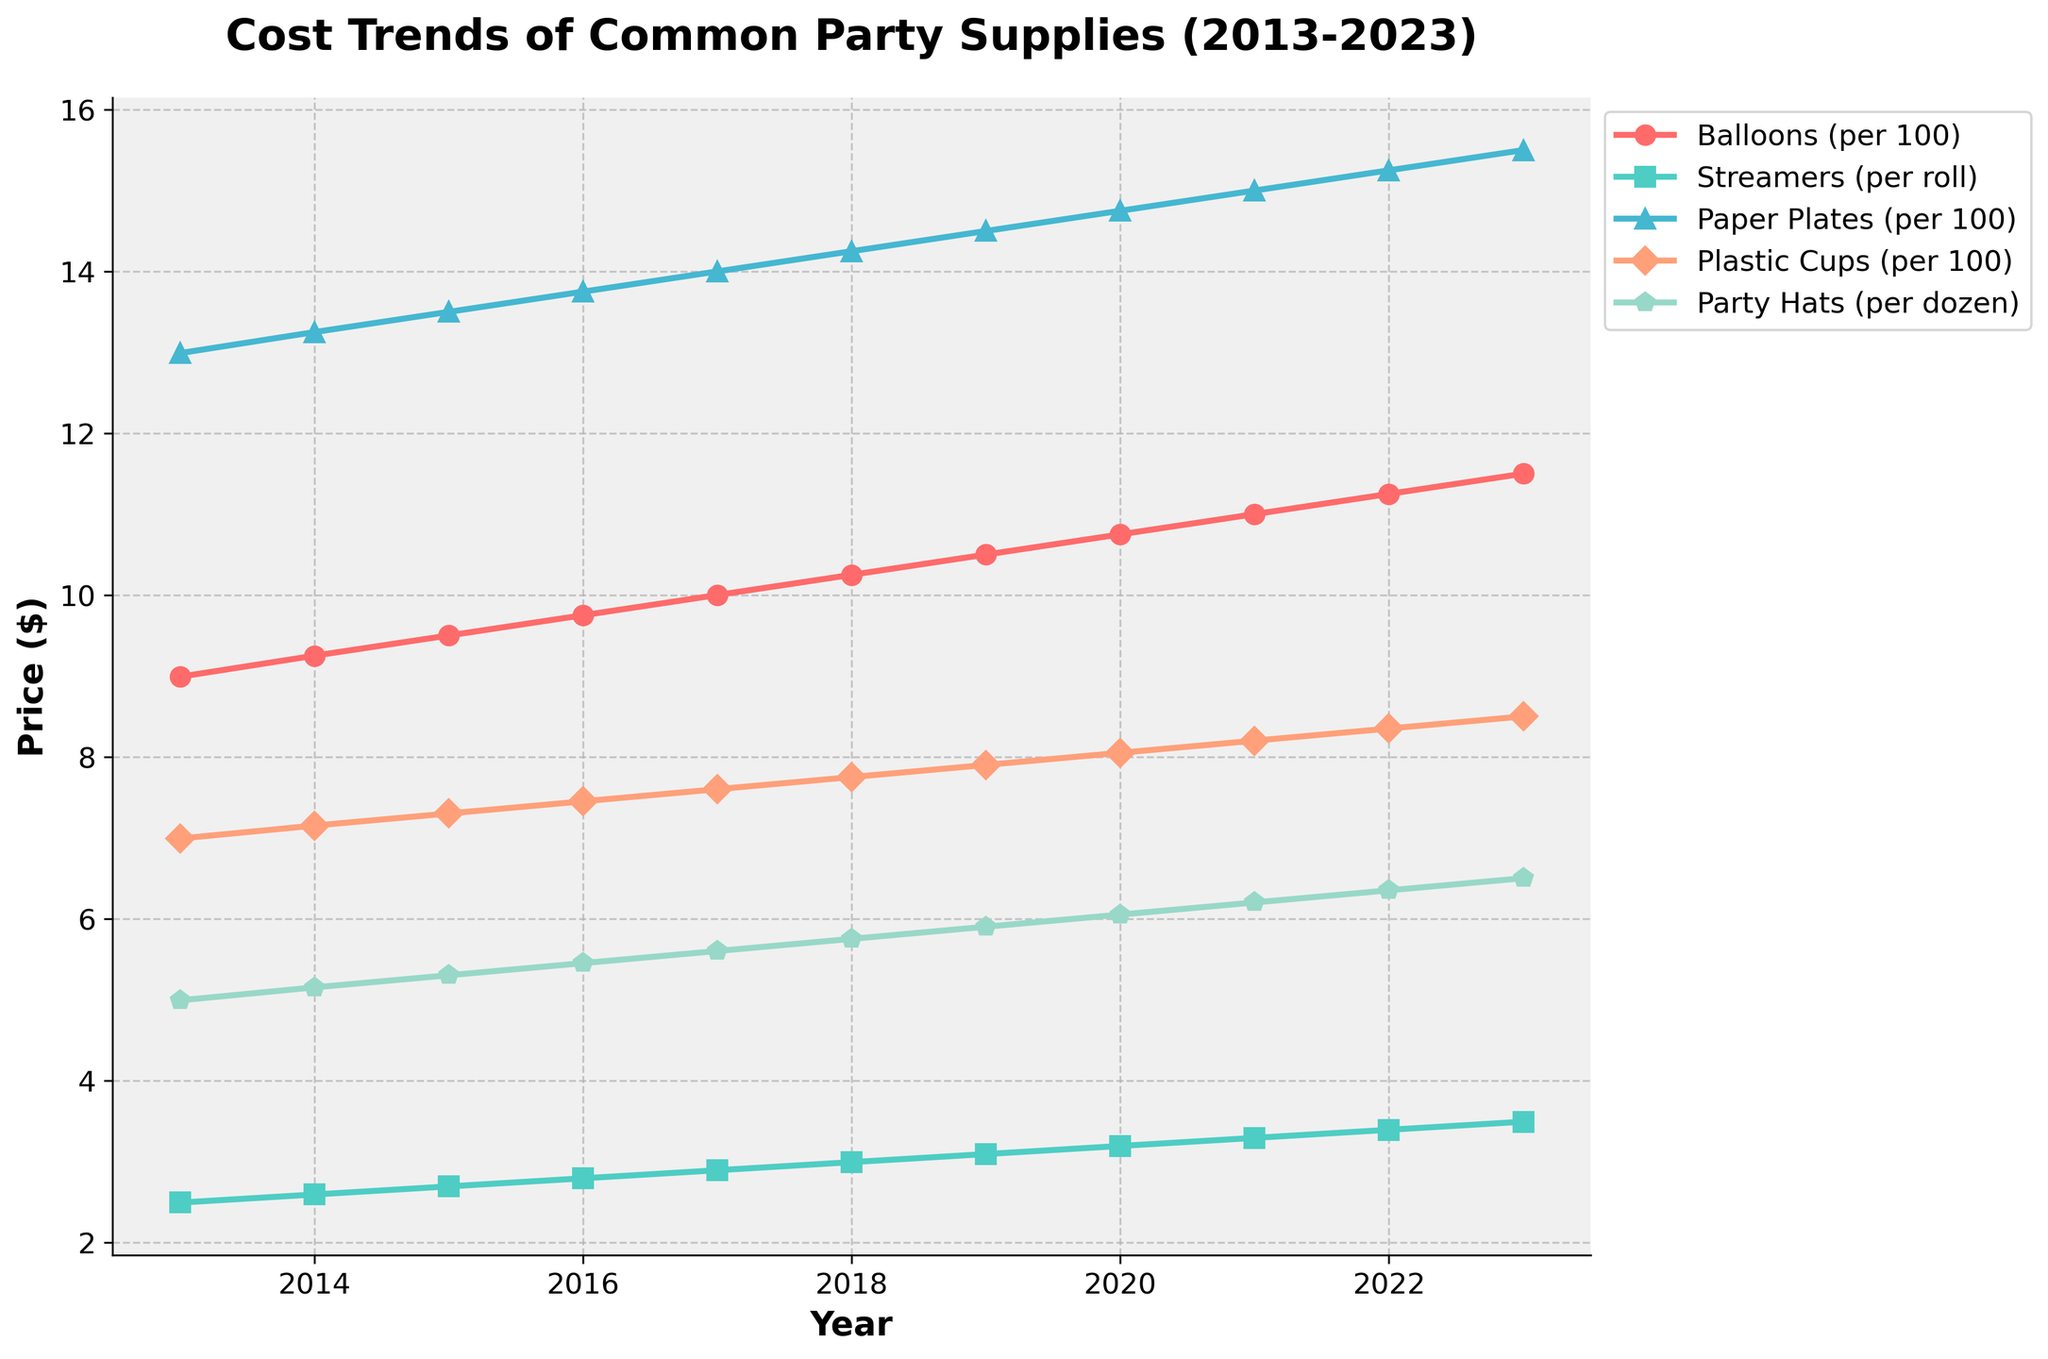What's the trend in the price of Party Hats from 2013 to 2023? The price of Party Hats has increased steadily from 2013 to 2023. Looking at the chart, we can observe that the price starts at $4.99 in 2013 and reaches $6.50 in 2023.
Answer: Steady increase Which item saw the largest price increase over the decade? By comparing the final prices in 2023 to their starting prices in 2013, we can calculate the increase for each item. Balloons increased by $2.51, Streamers by $1.00, Paper Plates by $2.51, Plastic Cups by $1.51, and Party Hats by $1.51. Therefore, Balloons and Paper Plates share the largest increases.
Answer: Balloons and Paper Plates How does the price of Plastic Cups in 2023 compare to its price in 2015? According to the chart, the price of Plastic Cups in 2015 was $7.30. In 2023, it is $8.50. To find the difference, we subtract the 2015 price from the 2023 price: $8.50 - $7.30 = $1.20.
Answer: $1.20 higher What's the average price of Paper Plates over the decade? To find the average, sum up the prices from 2013 to 2023 and then divide by the number of years. The prices are $12.99, $13.25, $13.50, $13.75, $14.00, $14.25, $14.50, $14.75, $15.00, $15.25, and $15.50, which sum up to $161.74. There are 11 years, so the average is $161.74 / 11 ≈ $14.70.
Answer: $14.70 In which year did Balloons and Streamers have the closest price difference? To find the year with the smallest price difference, look at the chart and compare the prices yearly. The closest difference occurs when the prices of Balloons and Streamers are nearest. In 2013, the difference is $6.50; in 2014, it's $6.66; and so on. The smallest difference is in 2023 with $8.01.
Answer: 2013 Are there any items whose prices did not rise every year? Analyze each item's trend in the chart. All items show a consistent year-over-year increase without any decreases.
Answer: No Which item was the least expensive in 2020? Looking at the prices for 2020, the costs are as follows: Balloons: $10.75, Streamers: $3.19, Paper Plates: $14.75, Plastic Cups: $8.05, and Party Hats: $6.05. Streamers have the lowest price in 2020.
Answer: Streamers How did the price of Streamers change between 2018 and 2023? The price of Streamers in 2018 was $2.99, and in 2023 it was $3.49. The difference is $3.49 - $2.99 = $0.50.
Answer: Increased by $0.50 What is the combined cost of 100 Balloons and a dozen Party Hats in 2023? According to the chart, the cost of Balloons in 2023 is $11.50, and the cost of Party Hats is $6.50. Combined, they cost $11.50 + $6.50 = $18.00.
Answer: $18.00 